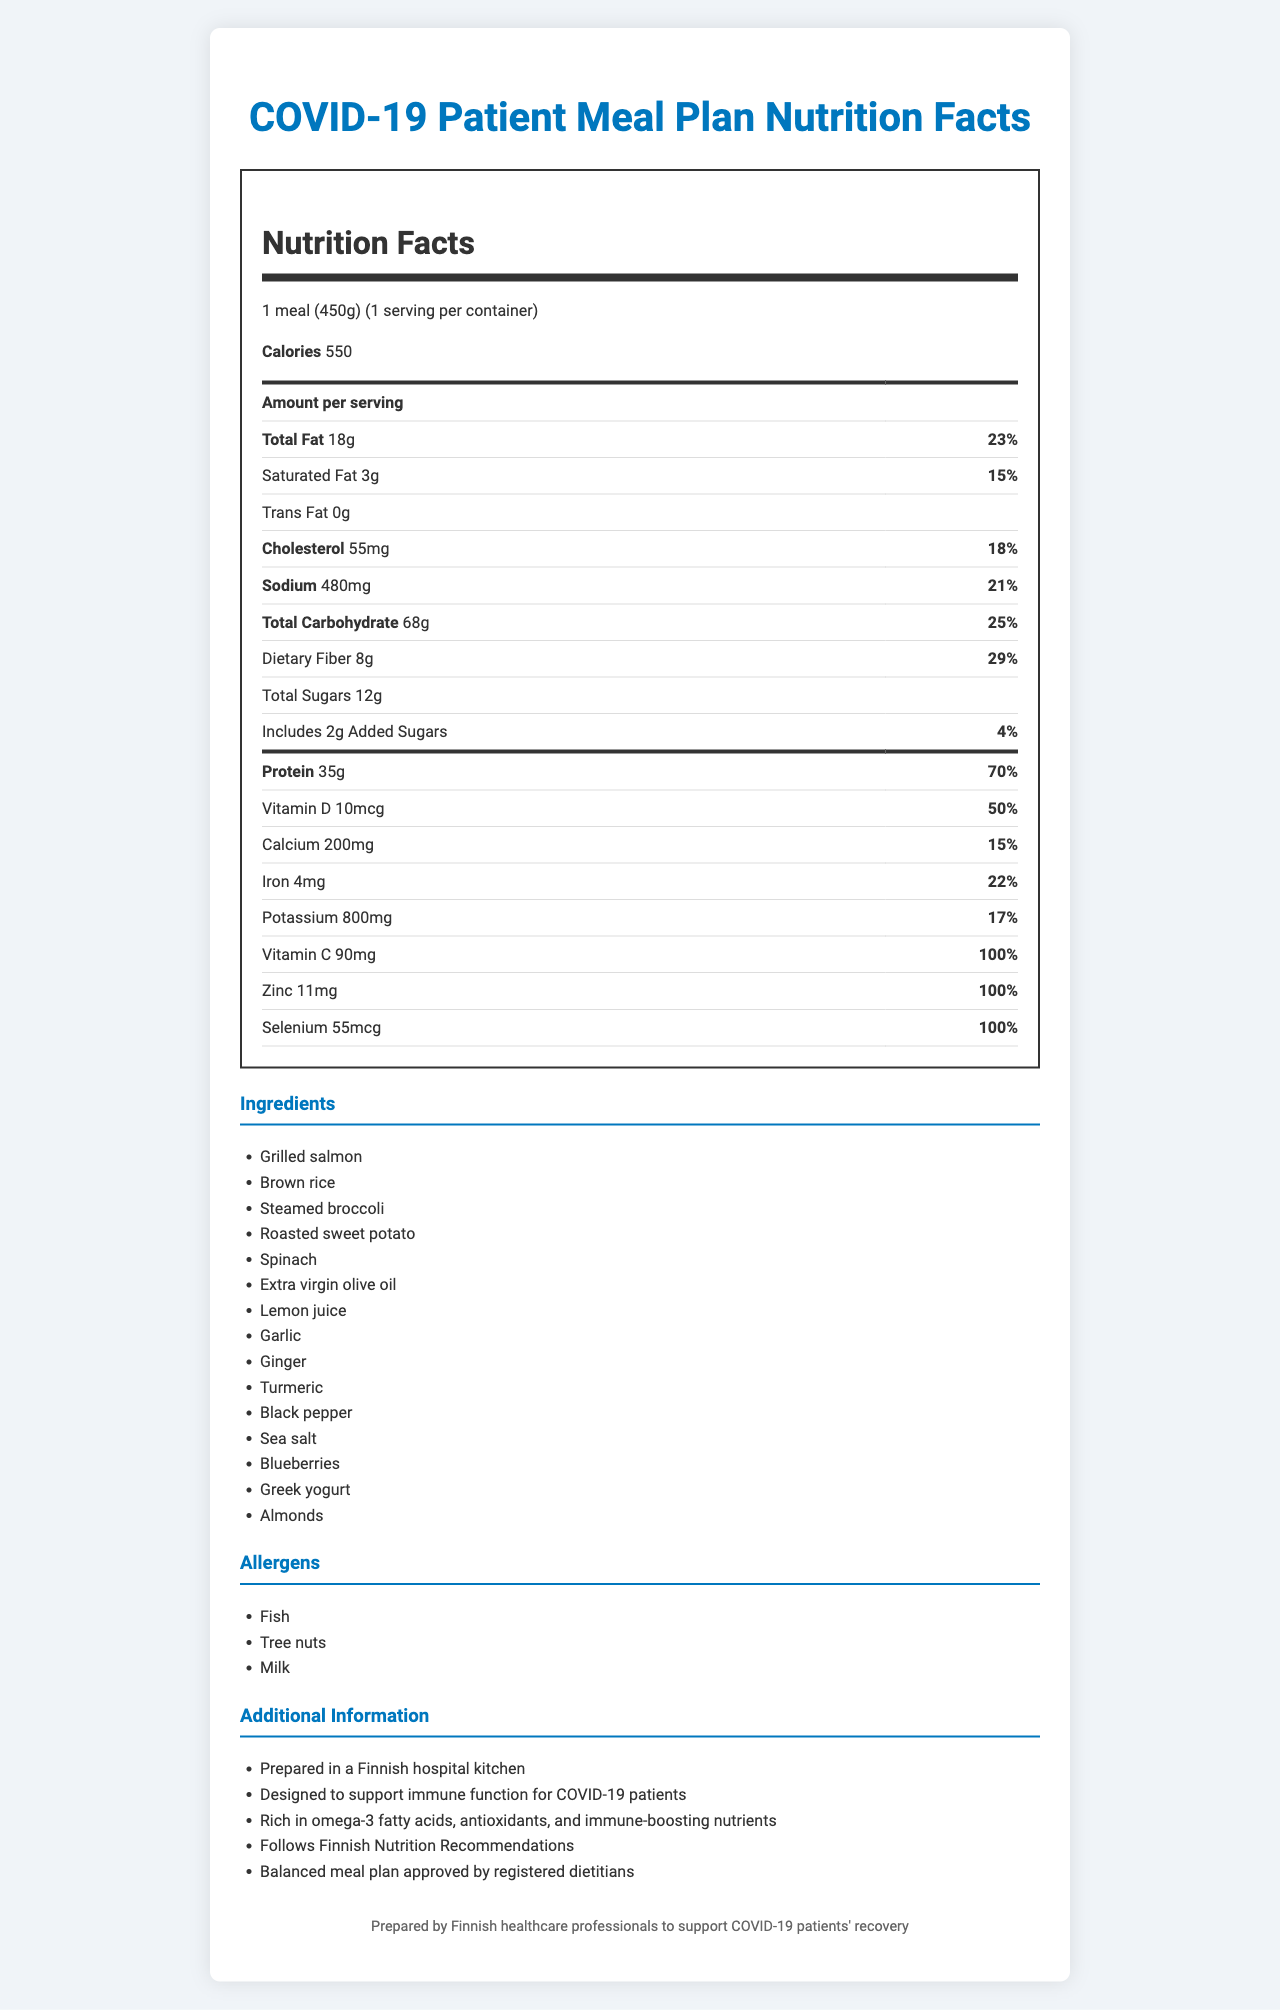what is the serving size for the meal? The serving size is listed at the beginning of the Nutrition Facts section of the document.
Answer: 1 meal (450g) how many calories are in one serving? The calorie count per serving is explicitly mentioned right under the serving size in the Nutrition Facts section.
Answer: 550 what is the total fat content per serving? The total fat content is listed as "Total Fat" in the nutrition label.
Answer: 18g how much dietary fiber is in the meal? The amount of dietary fiber can be found under the "Total Carbohydrate" section.
Answer: 8g what percentage of the daily value of protein does the meal provide? The percentage daily value for protein is listed as 70% in the nutrition label.
Answer: 70% which ingredient is an allergen? A. Brown rice B. Fish C. Greek yogurt D. All of the above The allergens listed in the document include fish (from grilled salmon), tree nuts (from almonds), and milk (from Greek yogurt).
Answer: D what is the amount of vitamin D in the meal? The Vitamin D content can be found towards the bottom of the Nutrition Facts table.
Answer: 10mcg does the meal contain any trans fat? Yes/No The document explicitly states that the trans fat content is 0g.
Answer: No is extra virgin olive oil included as an ingredient? Yes/No Extra virgin olive oil is listed among the ingredients.
Answer: Yes which nutrient in the meal has a daily value of 100%? A. Iron B. Zinc C. Calcium D. Potassium The document shows that Zinc has a percent daily value of 100%.
Answer: B describe the main idea of the document The document provides detailed nutritional information including calorie count, macronutrients, and micronutrients, as well as a list of ingredients and allergens. It also highlights that the meal plan follows Finnish Nutrition Recommendations and is prepared by healthcare professionals to support immune function.
Answer: The document outlines the nutrition facts and ingredients of a meal plan designed for COVID-19 patients, emphasizing balanced nutrition and immune-boosting components. what is the ingredient used for seasoning but not specifically listed under "spice"? Sea salt is listed as an ingredient and is typically used for seasoning.
Answer: Sea salt how much potassium does the meal contain? The amount of potassium is listed in the Nutrition Facts section towards the bottom.
Answer: 800mg how many grams of added sugars are included in the meal? The added sugars content is clearly listed in the Nutrition Facts section.
Answer: 2g what is the source of omega-3 fatty acids in the meal? The document mentions that the meal is rich in omega-3 fatty acids, and grilled salmon is known to be a good source of omega-3.
Answer: Grilled salmon does the meal follow Finnish Nutrition Recommendations? Yes/No It is explicitly mentioned in the additional info section that the meal follows Finnish Nutrition Recommendations.
Answer: Yes what is the iron content of the meal? The iron content can be found in the Nutrition Facts section.
Answer: 4mg what preparation method is used for the sweet potato? The document lists "Roasted sweet potato" in the ingredients section.
Answer: Roasted how much calcium does the meal provide as a percentage of the daily value? The calcium percent daily value is indicated as 15% in the Nutrition Facts section.
Answer: 15% what specific antioxidants does the meal contain? The document mentions that the meal is rich in antioxidants but does not specify which antioxidants are present.
Answer: Cannot be determined 